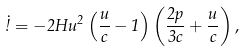<formula> <loc_0><loc_0><loc_500><loc_500>\dot { \omega } = - 2 H u ^ { 2 } \left ( \frac { u } { c } - 1 \right ) \left ( \frac { 2 p } { 3 c } + \frac { u } { c } \right ) ,</formula> 